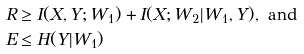Convert formula to latex. <formula><loc_0><loc_0><loc_500><loc_500>R & \geq I ( X , Y ; W _ { 1 } ) + I ( X ; W _ { 2 } | W _ { 1 } , Y ) , \text { and} \\ E & \leq H ( Y | W _ { 1 } )</formula> 